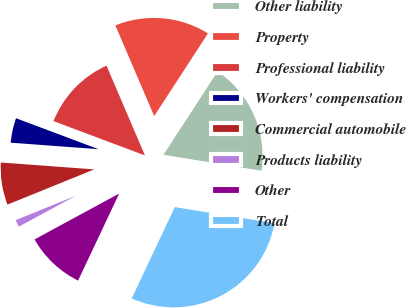Convert chart. <chart><loc_0><loc_0><loc_500><loc_500><pie_chart><fcel>Other liability<fcel>Property<fcel>Professional liability<fcel>Workers' compensation<fcel>Commercial automobile<fcel>Products liability<fcel>Other<fcel>Total<nl><fcel>18.39%<fcel>15.62%<fcel>12.85%<fcel>4.54%<fcel>7.31%<fcel>1.77%<fcel>10.08%<fcel>29.46%<nl></chart> 